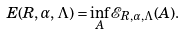Convert formula to latex. <formula><loc_0><loc_0><loc_500><loc_500>E ( R , \alpha , \Lambda ) = \inf _ { A } { \mathcal { E } } _ { R , \alpha , \Lambda } ( A ) .</formula> 